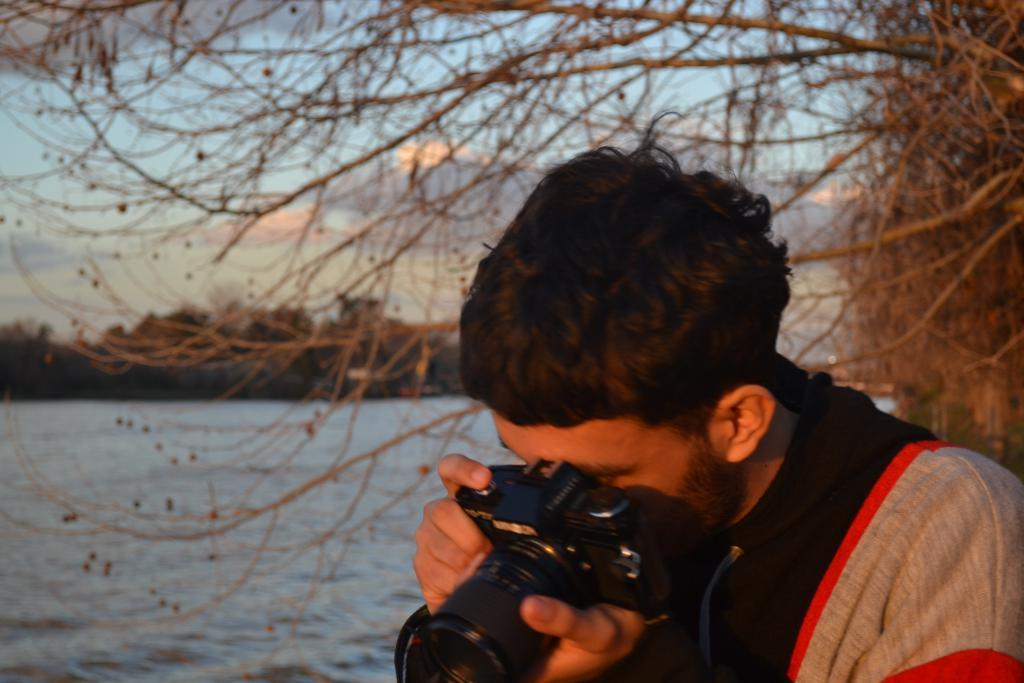Who is present in the image? There is a man in the image. Where is the man located in the image? The man is on the right side of the image. What is the man wearing? The man is wearing a t-shirt. What is the man holding in the image? The man is holding a camera. What can be seen in the background of the image? There are trees, waves, water, and the sky visible in the background of the image. What is the condition of the sky in the image? The sky is visible in the background of the image, and there are clouds present. What type of trouble is the man facing in the image? There is no indication of trouble in the image. --- Facts: 1. There is a car in the image. 12. The car is red. 13. The car has four wheels. 14. The car has a license plate. 15. The car is parked on the street. 16. There are buildings in the background of the image. 17. There are people walking on the sidewalk in the image. Absurd Topics: unicorn, rainbow, magic wand Conversation: What is the main subject in the image? There is a car in the image. What color is the car? The car is red. How many wheels does the car have? The car has four wheels. Does the car have a license plate? Yes, the car has a license plate. Where is the car located in the image? The car is parked on the street. What can be seen in the background of the image? There are buildings in the background of the image. Are there any people visible in the image? Yes, there are people walking on the sidewalk in the image. Reasoning: Let's think step by step in order to produce the conversation. We start by identifying the main subject in the image, which is the car. Then, we describe specific features of the car, such as its color, the number of wheels, and the presence of a license plate. Next, we observe the car's location in the image, which is parked on the street. After that, we describe the background of the image, which includes buildings. Finally, we acknowledge the presence of people in the image, who are walking on the sidewalk. Absurd Question/Answer: Can you see a unicorn in the image? No, there is no unicorn present in the image. --- Facts: 1. There is a cat in the image. 12. The cat is black and white. 13. The cat is sitting on a chair. 14. The cat is looking at something. 15. There is a bowl of water on the floor next to the chair. 16. There is 